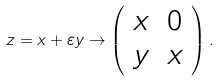Convert formula to latex. <formula><loc_0><loc_0><loc_500><loc_500>z = x + \varepsilon y \rightarrow \left ( \begin{array} { l l } x & 0 \\ y & x \\ \end{array} \right ) .</formula> 